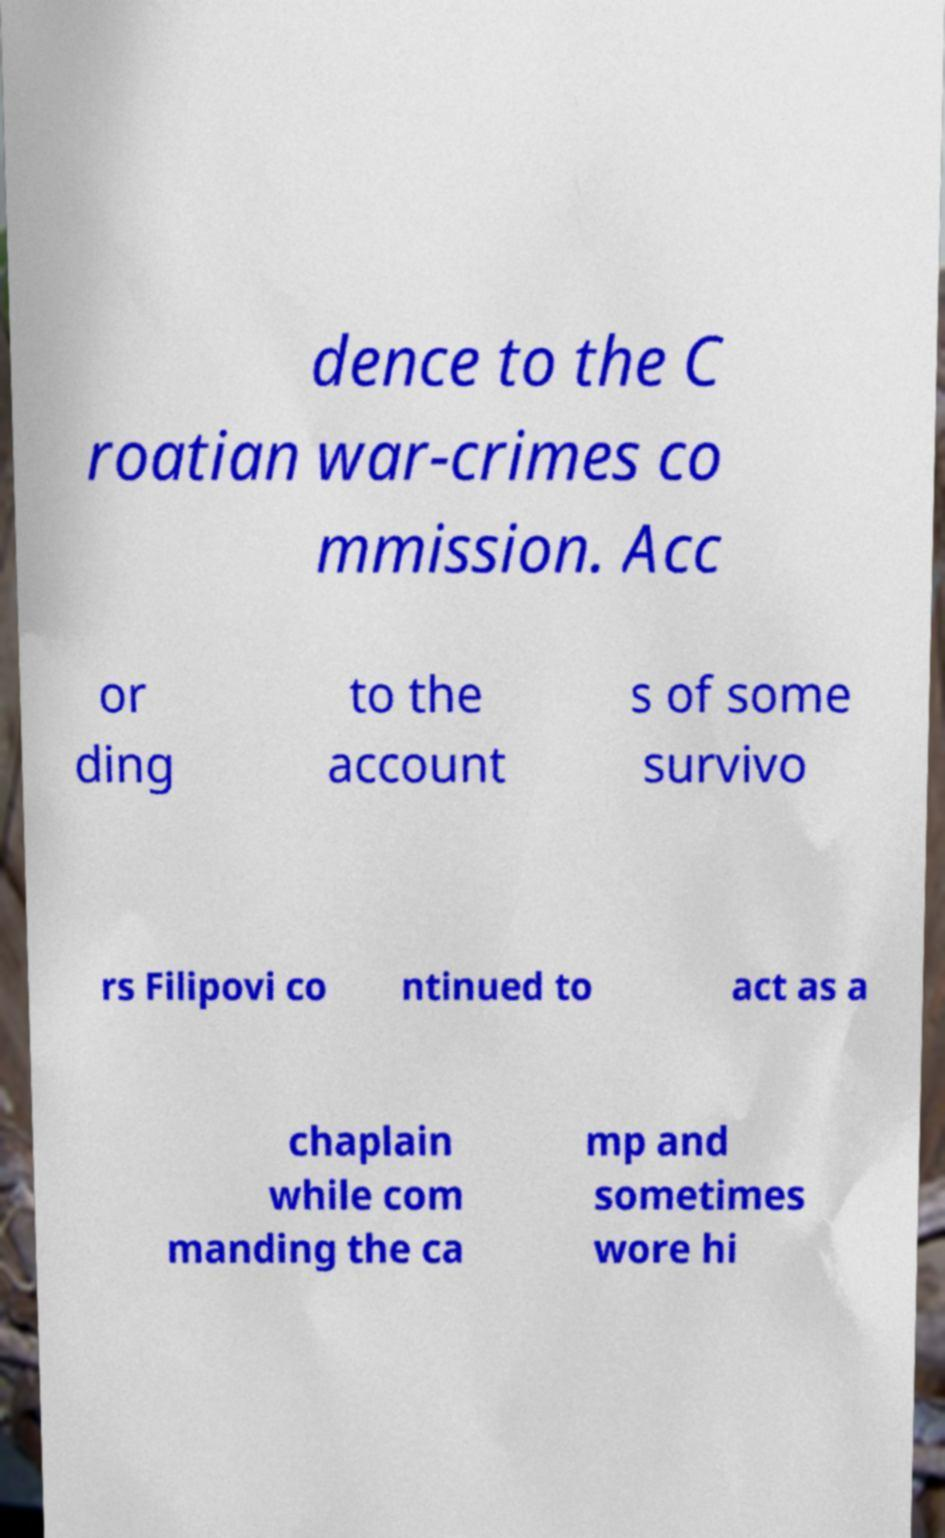What messages or text are displayed in this image? I need them in a readable, typed format. dence to the C roatian war-crimes co mmission. Acc or ding to the account s of some survivo rs Filipovi co ntinued to act as a chaplain while com manding the ca mp and sometimes wore hi 